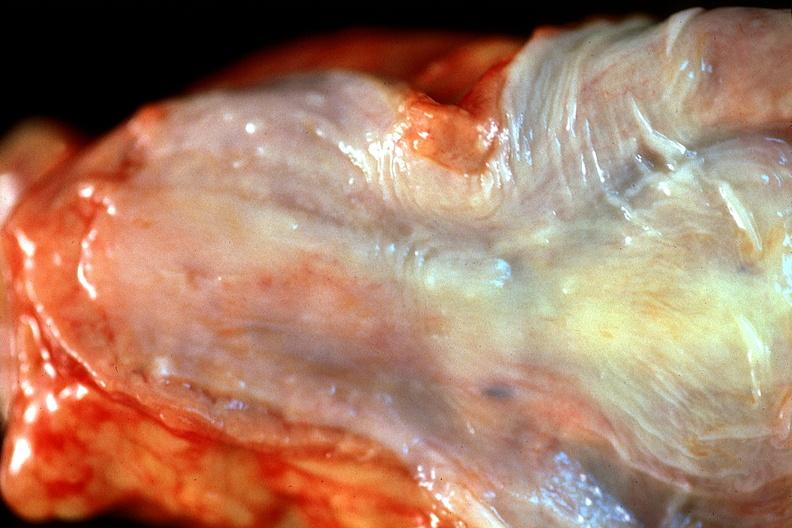what does this image show?
Answer the question using a single word or phrase. Normal esophagus 